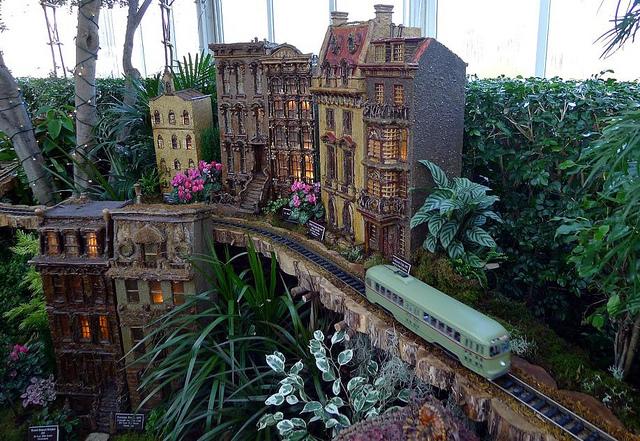Would the structures be called huts?
Concise answer only. No. What color is the bridge?
Keep it brief. Brown. What is the means of propulsion for the train?
Concise answer only. Electricity. Are there ranches in the picture?
Quick response, please. No. Is this a real train?
Write a very short answer. No. 